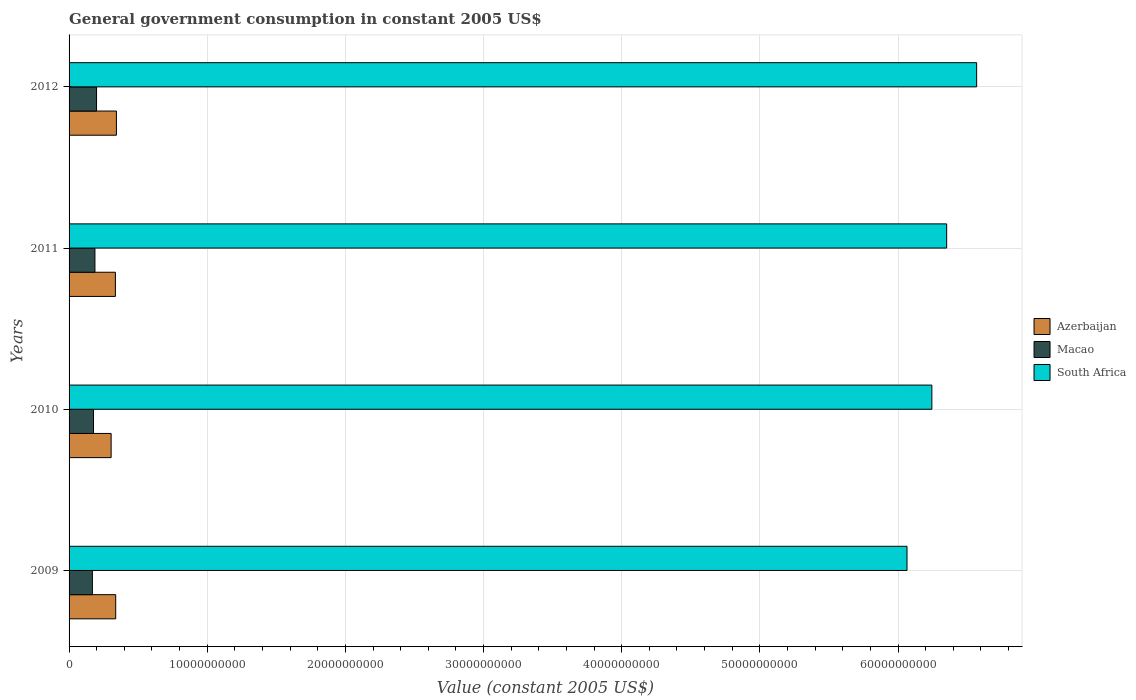Are the number of bars per tick equal to the number of legend labels?
Provide a succinct answer. Yes. Are the number of bars on each tick of the Y-axis equal?
Provide a succinct answer. Yes. How many bars are there on the 4th tick from the bottom?
Give a very brief answer. 3. What is the label of the 3rd group of bars from the top?
Ensure brevity in your answer.  2010. What is the government conusmption in Macao in 2010?
Keep it short and to the point. 1.77e+09. Across all years, what is the maximum government conusmption in South Africa?
Your answer should be compact. 6.57e+1. Across all years, what is the minimum government conusmption in South Africa?
Offer a terse response. 6.07e+1. In which year was the government conusmption in Macao minimum?
Ensure brevity in your answer.  2009. What is the total government conusmption in South Africa in the graph?
Offer a terse response. 2.52e+11. What is the difference between the government conusmption in Azerbaijan in 2009 and that in 2011?
Make the answer very short. 2.11e+07. What is the difference between the government conusmption in Azerbaijan in 2010 and the government conusmption in South Africa in 2011?
Offer a terse response. -6.05e+1. What is the average government conusmption in Macao per year?
Offer a terse response. 1.83e+09. In the year 2009, what is the difference between the government conusmption in South Africa and government conusmption in Macao?
Offer a very short reply. 5.90e+1. What is the ratio of the government conusmption in South Africa in 2010 to that in 2012?
Provide a succinct answer. 0.95. What is the difference between the highest and the second highest government conusmption in South Africa?
Ensure brevity in your answer.  2.17e+09. What is the difference between the highest and the lowest government conusmption in Macao?
Make the answer very short. 3.01e+08. In how many years, is the government conusmption in Macao greater than the average government conusmption in Macao taken over all years?
Make the answer very short. 2. Is the sum of the government conusmption in Macao in 2009 and 2012 greater than the maximum government conusmption in Azerbaijan across all years?
Keep it short and to the point. Yes. What does the 2nd bar from the top in 2011 represents?
Your answer should be compact. Macao. What does the 1st bar from the bottom in 2009 represents?
Provide a short and direct response. Azerbaijan. Are all the bars in the graph horizontal?
Ensure brevity in your answer.  Yes. How many years are there in the graph?
Keep it short and to the point. 4. Does the graph contain any zero values?
Offer a very short reply. No. Does the graph contain grids?
Your answer should be very brief. Yes. Where does the legend appear in the graph?
Your response must be concise. Center right. How are the legend labels stacked?
Provide a succinct answer. Vertical. What is the title of the graph?
Offer a very short reply. General government consumption in constant 2005 US$. Does "Europe(all income levels)" appear as one of the legend labels in the graph?
Your answer should be compact. No. What is the label or title of the X-axis?
Your response must be concise. Value (constant 2005 US$). What is the Value (constant 2005 US$) of Azerbaijan in 2009?
Offer a terse response. 3.37e+09. What is the Value (constant 2005 US$) in Macao in 2009?
Keep it short and to the point. 1.69e+09. What is the Value (constant 2005 US$) in South Africa in 2009?
Provide a short and direct response. 6.07e+1. What is the Value (constant 2005 US$) of Azerbaijan in 2010?
Make the answer very short. 3.04e+09. What is the Value (constant 2005 US$) in Macao in 2010?
Offer a terse response. 1.77e+09. What is the Value (constant 2005 US$) in South Africa in 2010?
Ensure brevity in your answer.  6.24e+1. What is the Value (constant 2005 US$) in Azerbaijan in 2011?
Your answer should be compact. 3.35e+09. What is the Value (constant 2005 US$) of Macao in 2011?
Keep it short and to the point. 1.87e+09. What is the Value (constant 2005 US$) in South Africa in 2011?
Your answer should be very brief. 6.35e+1. What is the Value (constant 2005 US$) in Azerbaijan in 2012?
Your answer should be compact. 3.43e+09. What is the Value (constant 2005 US$) in Macao in 2012?
Keep it short and to the point. 1.99e+09. What is the Value (constant 2005 US$) in South Africa in 2012?
Ensure brevity in your answer.  6.57e+1. Across all years, what is the maximum Value (constant 2005 US$) of Azerbaijan?
Provide a short and direct response. 3.43e+09. Across all years, what is the maximum Value (constant 2005 US$) in Macao?
Your response must be concise. 1.99e+09. Across all years, what is the maximum Value (constant 2005 US$) of South Africa?
Your answer should be compact. 6.57e+1. Across all years, what is the minimum Value (constant 2005 US$) in Azerbaijan?
Offer a very short reply. 3.04e+09. Across all years, what is the minimum Value (constant 2005 US$) in Macao?
Keep it short and to the point. 1.69e+09. Across all years, what is the minimum Value (constant 2005 US$) in South Africa?
Your answer should be very brief. 6.07e+1. What is the total Value (constant 2005 US$) in Azerbaijan in the graph?
Keep it short and to the point. 1.32e+1. What is the total Value (constant 2005 US$) in Macao in the graph?
Keep it short and to the point. 7.32e+09. What is the total Value (constant 2005 US$) of South Africa in the graph?
Your answer should be compact. 2.52e+11. What is the difference between the Value (constant 2005 US$) in Azerbaijan in 2009 and that in 2010?
Your answer should be compact. 3.31e+08. What is the difference between the Value (constant 2005 US$) in Macao in 2009 and that in 2010?
Your answer should be very brief. -8.23e+07. What is the difference between the Value (constant 2005 US$) of South Africa in 2009 and that in 2010?
Provide a succinct answer. -1.80e+09. What is the difference between the Value (constant 2005 US$) in Azerbaijan in 2009 and that in 2011?
Provide a short and direct response. 2.11e+07. What is the difference between the Value (constant 2005 US$) in Macao in 2009 and that in 2011?
Make the answer very short. -1.85e+08. What is the difference between the Value (constant 2005 US$) of South Africa in 2009 and that in 2011?
Ensure brevity in your answer.  -2.87e+09. What is the difference between the Value (constant 2005 US$) in Azerbaijan in 2009 and that in 2012?
Your answer should be compact. -5.27e+07. What is the difference between the Value (constant 2005 US$) in Macao in 2009 and that in 2012?
Your answer should be very brief. -3.01e+08. What is the difference between the Value (constant 2005 US$) of South Africa in 2009 and that in 2012?
Make the answer very short. -5.04e+09. What is the difference between the Value (constant 2005 US$) of Azerbaijan in 2010 and that in 2011?
Keep it short and to the point. -3.10e+08. What is the difference between the Value (constant 2005 US$) in Macao in 2010 and that in 2011?
Offer a terse response. -1.03e+08. What is the difference between the Value (constant 2005 US$) in South Africa in 2010 and that in 2011?
Your answer should be very brief. -1.07e+09. What is the difference between the Value (constant 2005 US$) in Azerbaijan in 2010 and that in 2012?
Make the answer very short. -3.84e+08. What is the difference between the Value (constant 2005 US$) in Macao in 2010 and that in 2012?
Your response must be concise. -2.19e+08. What is the difference between the Value (constant 2005 US$) of South Africa in 2010 and that in 2012?
Make the answer very short. -3.24e+09. What is the difference between the Value (constant 2005 US$) in Azerbaijan in 2011 and that in 2012?
Provide a succinct answer. -7.38e+07. What is the difference between the Value (constant 2005 US$) of Macao in 2011 and that in 2012?
Offer a very short reply. -1.16e+08. What is the difference between the Value (constant 2005 US$) of South Africa in 2011 and that in 2012?
Provide a succinct answer. -2.17e+09. What is the difference between the Value (constant 2005 US$) in Azerbaijan in 2009 and the Value (constant 2005 US$) in Macao in 2010?
Your response must be concise. 1.61e+09. What is the difference between the Value (constant 2005 US$) in Azerbaijan in 2009 and the Value (constant 2005 US$) in South Africa in 2010?
Your answer should be very brief. -5.91e+1. What is the difference between the Value (constant 2005 US$) in Macao in 2009 and the Value (constant 2005 US$) in South Africa in 2010?
Ensure brevity in your answer.  -6.08e+1. What is the difference between the Value (constant 2005 US$) in Azerbaijan in 2009 and the Value (constant 2005 US$) in Macao in 2011?
Ensure brevity in your answer.  1.50e+09. What is the difference between the Value (constant 2005 US$) in Azerbaijan in 2009 and the Value (constant 2005 US$) in South Africa in 2011?
Provide a short and direct response. -6.01e+1. What is the difference between the Value (constant 2005 US$) in Macao in 2009 and the Value (constant 2005 US$) in South Africa in 2011?
Give a very brief answer. -6.18e+1. What is the difference between the Value (constant 2005 US$) in Azerbaijan in 2009 and the Value (constant 2005 US$) in Macao in 2012?
Your response must be concise. 1.39e+09. What is the difference between the Value (constant 2005 US$) of Azerbaijan in 2009 and the Value (constant 2005 US$) of South Africa in 2012?
Give a very brief answer. -6.23e+1. What is the difference between the Value (constant 2005 US$) of Macao in 2009 and the Value (constant 2005 US$) of South Africa in 2012?
Provide a short and direct response. -6.40e+1. What is the difference between the Value (constant 2005 US$) of Azerbaijan in 2010 and the Value (constant 2005 US$) of Macao in 2011?
Offer a very short reply. 1.17e+09. What is the difference between the Value (constant 2005 US$) in Azerbaijan in 2010 and the Value (constant 2005 US$) in South Africa in 2011?
Provide a short and direct response. -6.05e+1. What is the difference between the Value (constant 2005 US$) of Macao in 2010 and the Value (constant 2005 US$) of South Africa in 2011?
Offer a terse response. -6.18e+1. What is the difference between the Value (constant 2005 US$) of Azerbaijan in 2010 and the Value (constant 2005 US$) of Macao in 2012?
Keep it short and to the point. 1.06e+09. What is the difference between the Value (constant 2005 US$) in Azerbaijan in 2010 and the Value (constant 2005 US$) in South Africa in 2012?
Keep it short and to the point. -6.26e+1. What is the difference between the Value (constant 2005 US$) in Macao in 2010 and the Value (constant 2005 US$) in South Africa in 2012?
Offer a very short reply. -6.39e+1. What is the difference between the Value (constant 2005 US$) of Azerbaijan in 2011 and the Value (constant 2005 US$) of Macao in 2012?
Your response must be concise. 1.37e+09. What is the difference between the Value (constant 2005 US$) of Azerbaijan in 2011 and the Value (constant 2005 US$) of South Africa in 2012?
Your answer should be very brief. -6.23e+1. What is the difference between the Value (constant 2005 US$) in Macao in 2011 and the Value (constant 2005 US$) in South Africa in 2012?
Make the answer very short. -6.38e+1. What is the average Value (constant 2005 US$) in Azerbaijan per year?
Make the answer very short. 3.30e+09. What is the average Value (constant 2005 US$) in Macao per year?
Make the answer very short. 1.83e+09. What is the average Value (constant 2005 US$) in South Africa per year?
Give a very brief answer. 6.31e+1. In the year 2009, what is the difference between the Value (constant 2005 US$) in Azerbaijan and Value (constant 2005 US$) in Macao?
Your response must be concise. 1.69e+09. In the year 2009, what is the difference between the Value (constant 2005 US$) of Azerbaijan and Value (constant 2005 US$) of South Africa?
Offer a very short reply. -5.73e+1. In the year 2009, what is the difference between the Value (constant 2005 US$) in Macao and Value (constant 2005 US$) in South Africa?
Give a very brief answer. -5.90e+1. In the year 2010, what is the difference between the Value (constant 2005 US$) in Azerbaijan and Value (constant 2005 US$) in Macao?
Offer a very short reply. 1.27e+09. In the year 2010, what is the difference between the Value (constant 2005 US$) in Azerbaijan and Value (constant 2005 US$) in South Africa?
Ensure brevity in your answer.  -5.94e+1. In the year 2010, what is the difference between the Value (constant 2005 US$) of Macao and Value (constant 2005 US$) of South Africa?
Provide a succinct answer. -6.07e+1. In the year 2011, what is the difference between the Value (constant 2005 US$) of Azerbaijan and Value (constant 2005 US$) of Macao?
Offer a terse response. 1.48e+09. In the year 2011, what is the difference between the Value (constant 2005 US$) of Azerbaijan and Value (constant 2005 US$) of South Africa?
Offer a very short reply. -6.02e+1. In the year 2011, what is the difference between the Value (constant 2005 US$) of Macao and Value (constant 2005 US$) of South Africa?
Offer a terse response. -6.16e+1. In the year 2012, what is the difference between the Value (constant 2005 US$) in Azerbaijan and Value (constant 2005 US$) in Macao?
Ensure brevity in your answer.  1.44e+09. In the year 2012, what is the difference between the Value (constant 2005 US$) of Azerbaijan and Value (constant 2005 US$) of South Africa?
Keep it short and to the point. -6.23e+1. In the year 2012, what is the difference between the Value (constant 2005 US$) in Macao and Value (constant 2005 US$) in South Africa?
Your response must be concise. -6.37e+1. What is the ratio of the Value (constant 2005 US$) in Azerbaijan in 2009 to that in 2010?
Ensure brevity in your answer.  1.11. What is the ratio of the Value (constant 2005 US$) in Macao in 2009 to that in 2010?
Provide a succinct answer. 0.95. What is the ratio of the Value (constant 2005 US$) in South Africa in 2009 to that in 2010?
Your answer should be compact. 0.97. What is the ratio of the Value (constant 2005 US$) of Azerbaijan in 2009 to that in 2011?
Your answer should be very brief. 1.01. What is the ratio of the Value (constant 2005 US$) of Macao in 2009 to that in 2011?
Offer a very short reply. 0.9. What is the ratio of the Value (constant 2005 US$) of South Africa in 2009 to that in 2011?
Make the answer very short. 0.95. What is the ratio of the Value (constant 2005 US$) in Azerbaijan in 2009 to that in 2012?
Keep it short and to the point. 0.98. What is the ratio of the Value (constant 2005 US$) of Macao in 2009 to that in 2012?
Give a very brief answer. 0.85. What is the ratio of the Value (constant 2005 US$) of South Africa in 2009 to that in 2012?
Offer a very short reply. 0.92. What is the ratio of the Value (constant 2005 US$) in Azerbaijan in 2010 to that in 2011?
Your response must be concise. 0.91. What is the ratio of the Value (constant 2005 US$) of Macao in 2010 to that in 2011?
Give a very brief answer. 0.95. What is the ratio of the Value (constant 2005 US$) of South Africa in 2010 to that in 2011?
Keep it short and to the point. 0.98. What is the ratio of the Value (constant 2005 US$) of Azerbaijan in 2010 to that in 2012?
Ensure brevity in your answer.  0.89. What is the ratio of the Value (constant 2005 US$) in Macao in 2010 to that in 2012?
Keep it short and to the point. 0.89. What is the ratio of the Value (constant 2005 US$) of South Africa in 2010 to that in 2012?
Offer a terse response. 0.95. What is the ratio of the Value (constant 2005 US$) in Azerbaijan in 2011 to that in 2012?
Offer a very short reply. 0.98. What is the ratio of the Value (constant 2005 US$) of Macao in 2011 to that in 2012?
Keep it short and to the point. 0.94. What is the ratio of the Value (constant 2005 US$) in South Africa in 2011 to that in 2012?
Your answer should be very brief. 0.97. What is the difference between the highest and the second highest Value (constant 2005 US$) of Azerbaijan?
Your response must be concise. 5.27e+07. What is the difference between the highest and the second highest Value (constant 2005 US$) of Macao?
Ensure brevity in your answer.  1.16e+08. What is the difference between the highest and the second highest Value (constant 2005 US$) in South Africa?
Ensure brevity in your answer.  2.17e+09. What is the difference between the highest and the lowest Value (constant 2005 US$) of Azerbaijan?
Your answer should be very brief. 3.84e+08. What is the difference between the highest and the lowest Value (constant 2005 US$) of Macao?
Offer a very short reply. 3.01e+08. What is the difference between the highest and the lowest Value (constant 2005 US$) in South Africa?
Ensure brevity in your answer.  5.04e+09. 